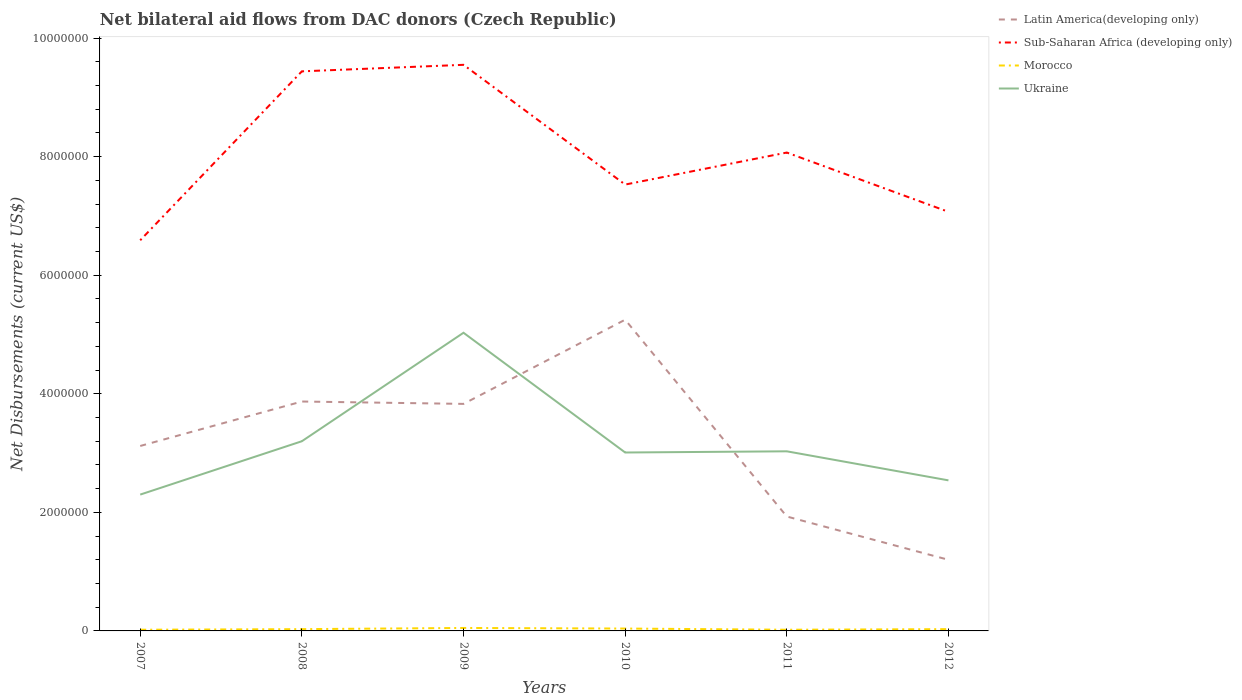Is the number of lines equal to the number of legend labels?
Give a very brief answer. Yes. Across all years, what is the maximum net bilateral aid flows in Sub-Saharan Africa (developing only)?
Provide a succinct answer. 6.59e+06. What is the total net bilateral aid flows in Latin America(developing only) in the graph?
Your response must be concise. -7.10e+05. What is the difference between the highest and the second highest net bilateral aid flows in Sub-Saharan Africa (developing only)?
Provide a short and direct response. 2.96e+06. Is the net bilateral aid flows in Morocco strictly greater than the net bilateral aid flows in Ukraine over the years?
Your answer should be very brief. Yes. How many years are there in the graph?
Provide a short and direct response. 6. What is the difference between two consecutive major ticks on the Y-axis?
Your response must be concise. 2.00e+06. Does the graph contain any zero values?
Give a very brief answer. No. Does the graph contain grids?
Offer a terse response. No. What is the title of the graph?
Your response must be concise. Net bilateral aid flows from DAC donors (Czech Republic). What is the label or title of the X-axis?
Give a very brief answer. Years. What is the label or title of the Y-axis?
Keep it short and to the point. Net Disbursements (current US$). What is the Net Disbursements (current US$) in Latin America(developing only) in 2007?
Give a very brief answer. 3.12e+06. What is the Net Disbursements (current US$) in Sub-Saharan Africa (developing only) in 2007?
Your answer should be very brief. 6.59e+06. What is the Net Disbursements (current US$) in Ukraine in 2007?
Give a very brief answer. 2.30e+06. What is the Net Disbursements (current US$) in Latin America(developing only) in 2008?
Offer a terse response. 3.87e+06. What is the Net Disbursements (current US$) of Sub-Saharan Africa (developing only) in 2008?
Your response must be concise. 9.44e+06. What is the Net Disbursements (current US$) of Morocco in 2008?
Make the answer very short. 3.00e+04. What is the Net Disbursements (current US$) of Ukraine in 2008?
Provide a short and direct response. 3.20e+06. What is the Net Disbursements (current US$) in Latin America(developing only) in 2009?
Your answer should be compact. 3.83e+06. What is the Net Disbursements (current US$) in Sub-Saharan Africa (developing only) in 2009?
Offer a terse response. 9.55e+06. What is the Net Disbursements (current US$) of Morocco in 2009?
Offer a very short reply. 5.00e+04. What is the Net Disbursements (current US$) in Ukraine in 2009?
Ensure brevity in your answer.  5.03e+06. What is the Net Disbursements (current US$) in Latin America(developing only) in 2010?
Offer a very short reply. 5.25e+06. What is the Net Disbursements (current US$) of Sub-Saharan Africa (developing only) in 2010?
Offer a very short reply. 7.53e+06. What is the Net Disbursements (current US$) of Morocco in 2010?
Your answer should be very brief. 4.00e+04. What is the Net Disbursements (current US$) in Ukraine in 2010?
Your response must be concise. 3.01e+06. What is the Net Disbursements (current US$) in Latin America(developing only) in 2011?
Offer a terse response. 1.93e+06. What is the Net Disbursements (current US$) in Sub-Saharan Africa (developing only) in 2011?
Provide a short and direct response. 8.07e+06. What is the Net Disbursements (current US$) in Morocco in 2011?
Your response must be concise. 2.00e+04. What is the Net Disbursements (current US$) in Ukraine in 2011?
Your answer should be very brief. 3.03e+06. What is the Net Disbursements (current US$) in Latin America(developing only) in 2012?
Provide a succinct answer. 1.20e+06. What is the Net Disbursements (current US$) in Sub-Saharan Africa (developing only) in 2012?
Provide a succinct answer. 7.07e+06. What is the Net Disbursements (current US$) in Ukraine in 2012?
Your answer should be compact. 2.54e+06. Across all years, what is the maximum Net Disbursements (current US$) of Latin America(developing only)?
Offer a very short reply. 5.25e+06. Across all years, what is the maximum Net Disbursements (current US$) in Sub-Saharan Africa (developing only)?
Keep it short and to the point. 9.55e+06. Across all years, what is the maximum Net Disbursements (current US$) of Ukraine?
Make the answer very short. 5.03e+06. Across all years, what is the minimum Net Disbursements (current US$) of Latin America(developing only)?
Your answer should be very brief. 1.20e+06. Across all years, what is the minimum Net Disbursements (current US$) in Sub-Saharan Africa (developing only)?
Ensure brevity in your answer.  6.59e+06. Across all years, what is the minimum Net Disbursements (current US$) in Ukraine?
Offer a very short reply. 2.30e+06. What is the total Net Disbursements (current US$) in Latin America(developing only) in the graph?
Your answer should be very brief. 1.92e+07. What is the total Net Disbursements (current US$) of Sub-Saharan Africa (developing only) in the graph?
Provide a short and direct response. 4.82e+07. What is the total Net Disbursements (current US$) in Morocco in the graph?
Keep it short and to the point. 1.90e+05. What is the total Net Disbursements (current US$) of Ukraine in the graph?
Your answer should be compact. 1.91e+07. What is the difference between the Net Disbursements (current US$) of Latin America(developing only) in 2007 and that in 2008?
Give a very brief answer. -7.50e+05. What is the difference between the Net Disbursements (current US$) in Sub-Saharan Africa (developing only) in 2007 and that in 2008?
Provide a succinct answer. -2.85e+06. What is the difference between the Net Disbursements (current US$) of Ukraine in 2007 and that in 2008?
Provide a short and direct response. -9.00e+05. What is the difference between the Net Disbursements (current US$) of Latin America(developing only) in 2007 and that in 2009?
Give a very brief answer. -7.10e+05. What is the difference between the Net Disbursements (current US$) of Sub-Saharan Africa (developing only) in 2007 and that in 2009?
Provide a short and direct response. -2.96e+06. What is the difference between the Net Disbursements (current US$) in Morocco in 2007 and that in 2009?
Your answer should be very brief. -3.00e+04. What is the difference between the Net Disbursements (current US$) of Ukraine in 2007 and that in 2009?
Your answer should be compact. -2.73e+06. What is the difference between the Net Disbursements (current US$) of Latin America(developing only) in 2007 and that in 2010?
Ensure brevity in your answer.  -2.13e+06. What is the difference between the Net Disbursements (current US$) in Sub-Saharan Africa (developing only) in 2007 and that in 2010?
Your answer should be compact. -9.40e+05. What is the difference between the Net Disbursements (current US$) in Ukraine in 2007 and that in 2010?
Your response must be concise. -7.10e+05. What is the difference between the Net Disbursements (current US$) in Latin America(developing only) in 2007 and that in 2011?
Keep it short and to the point. 1.19e+06. What is the difference between the Net Disbursements (current US$) of Sub-Saharan Africa (developing only) in 2007 and that in 2011?
Offer a very short reply. -1.48e+06. What is the difference between the Net Disbursements (current US$) in Ukraine in 2007 and that in 2011?
Your answer should be compact. -7.30e+05. What is the difference between the Net Disbursements (current US$) of Latin America(developing only) in 2007 and that in 2012?
Your answer should be compact. 1.92e+06. What is the difference between the Net Disbursements (current US$) of Sub-Saharan Africa (developing only) in 2007 and that in 2012?
Provide a succinct answer. -4.80e+05. What is the difference between the Net Disbursements (current US$) of Morocco in 2007 and that in 2012?
Provide a succinct answer. -10000. What is the difference between the Net Disbursements (current US$) in Sub-Saharan Africa (developing only) in 2008 and that in 2009?
Make the answer very short. -1.10e+05. What is the difference between the Net Disbursements (current US$) of Morocco in 2008 and that in 2009?
Ensure brevity in your answer.  -2.00e+04. What is the difference between the Net Disbursements (current US$) in Ukraine in 2008 and that in 2009?
Offer a terse response. -1.83e+06. What is the difference between the Net Disbursements (current US$) in Latin America(developing only) in 2008 and that in 2010?
Offer a very short reply. -1.38e+06. What is the difference between the Net Disbursements (current US$) in Sub-Saharan Africa (developing only) in 2008 and that in 2010?
Your answer should be very brief. 1.91e+06. What is the difference between the Net Disbursements (current US$) of Morocco in 2008 and that in 2010?
Your answer should be very brief. -10000. What is the difference between the Net Disbursements (current US$) in Ukraine in 2008 and that in 2010?
Offer a very short reply. 1.90e+05. What is the difference between the Net Disbursements (current US$) of Latin America(developing only) in 2008 and that in 2011?
Offer a very short reply. 1.94e+06. What is the difference between the Net Disbursements (current US$) in Sub-Saharan Africa (developing only) in 2008 and that in 2011?
Your answer should be compact. 1.37e+06. What is the difference between the Net Disbursements (current US$) of Ukraine in 2008 and that in 2011?
Make the answer very short. 1.70e+05. What is the difference between the Net Disbursements (current US$) of Latin America(developing only) in 2008 and that in 2012?
Ensure brevity in your answer.  2.67e+06. What is the difference between the Net Disbursements (current US$) in Sub-Saharan Africa (developing only) in 2008 and that in 2012?
Keep it short and to the point. 2.37e+06. What is the difference between the Net Disbursements (current US$) of Morocco in 2008 and that in 2012?
Your answer should be very brief. 0. What is the difference between the Net Disbursements (current US$) of Ukraine in 2008 and that in 2012?
Give a very brief answer. 6.60e+05. What is the difference between the Net Disbursements (current US$) of Latin America(developing only) in 2009 and that in 2010?
Your response must be concise. -1.42e+06. What is the difference between the Net Disbursements (current US$) in Sub-Saharan Africa (developing only) in 2009 and that in 2010?
Make the answer very short. 2.02e+06. What is the difference between the Net Disbursements (current US$) of Ukraine in 2009 and that in 2010?
Your response must be concise. 2.02e+06. What is the difference between the Net Disbursements (current US$) in Latin America(developing only) in 2009 and that in 2011?
Provide a short and direct response. 1.90e+06. What is the difference between the Net Disbursements (current US$) in Sub-Saharan Africa (developing only) in 2009 and that in 2011?
Provide a short and direct response. 1.48e+06. What is the difference between the Net Disbursements (current US$) of Morocco in 2009 and that in 2011?
Provide a short and direct response. 3.00e+04. What is the difference between the Net Disbursements (current US$) of Ukraine in 2009 and that in 2011?
Provide a succinct answer. 2.00e+06. What is the difference between the Net Disbursements (current US$) of Latin America(developing only) in 2009 and that in 2012?
Your answer should be very brief. 2.63e+06. What is the difference between the Net Disbursements (current US$) of Sub-Saharan Africa (developing only) in 2009 and that in 2012?
Your answer should be compact. 2.48e+06. What is the difference between the Net Disbursements (current US$) of Ukraine in 2009 and that in 2012?
Make the answer very short. 2.49e+06. What is the difference between the Net Disbursements (current US$) in Latin America(developing only) in 2010 and that in 2011?
Ensure brevity in your answer.  3.32e+06. What is the difference between the Net Disbursements (current US$) in Sub-Saharan Africa (developing only) in 2010 and that in 2011?
Make the answer very short. -5.40e+05. What is the difference between the Net Disbursements (current US$) in Morocco in 2010 and that in 2011?
Provide a succinct answer. 2.00e+04. What is the difference between the Net Disbursements (current US$) in Ukraine in 2010 and that in 2011?
Provide a short and direct response. -2.00e+04. What is the difference between the Net Disbursements (current US$) of Latin America(developing only) in 2010 and that in 2012?
Your answer should be very brief. 4.05e+06. What is the difference between the Net Disbursements (current US$) of Ukraine in 2010 and that in 2012?
Your response must be concise. 4.70e+05. What is the difference between the Net Disbursements (current US$) of Latin America(developing only) in 2011 and that in 2012?
Your answer should be very brief. 7.30e+05. What is the difference between the Net Disbursements (current US$) of Sub-Saharan Africa (developing only) in 2011 and that in 2012?
Offer a very short reply. 1.00e+06. What is the difference between the Net Disbursements (current US$) of Ukraine in 2011 and that in 2012?
Make the answer very short. 4.90e+05. What is the difference between the Net Disbursements (current US$) in Latin America(developing only) in 2007 and the Net Disbursements (current US$) in Sub-Saharan Africa (developing only) in 2008?
Your answer should be compact. -6.32e+06. What is the difference between the Net Disbursements (current US$) of Latin America(developing only) in 2007 and the Net Disbursements (current US$) of Morocco in 2008?
Ensure brevity in your answer.  3.09e+06. What is the difference between the Net Disbursements (current US$) of Latin America(developing only) in 2007 and the Net Disbursements (current US$) of Ukraine in 2008?
Make the answer very short. -8.00e+04. What is the difference between the Net Disbursements (current US$) of Sub-Saharan Africa (developing only) in 2007 and the Net Disbursements (current US$) of Morocco in 2008?
Provide a succinct answer. 6.56e+06. What is the difference between the Net Disbursements (current US$) of Sub-Saharan Africa (developing only) in 2007 and the Net Disbursements (current US$) of Ukraine in 2008?
Provide a short and direct response. 3.39e+06. What is the difference between the Net Disbursements (current US$) in Morocco in 2007 and the Net Disbursements (current US$) in Ukraine in 2008?
Make the answer very short. -3.18e+06. What is the difference between the Net Disbursements (current US$) in Latin America(developing only) in 2007 and the Net Disbursements (current US$) in Sub-Saharan Africa (developing only) in 2009?
Provide a succinct answer. -6.43e+06. What is the difference between the Net Disbursements (current US$) of Latin America(developing only) in 2007 and the Net Disbursements (current US$) of Morocco in 2009?
Make the answer very short. 3.07e+06. What is the difference between the Net Disbursements (current US$) in Latin America(developing only) in 2007 and the Net Disbursements (current US$) in Ukraine in 2009?
Ensure brevity in your answer.  -1.91e+06. What is the difference between the Net Disbursements (current US$) of Sub-Saharan Africa (developing only) in 2007 and the Net Disbursements (current US$) of Morocco in 2009?
Your answer should be very brief. 6.54e+06. What is the difference between the Net Disbursements (current US$) of Sub-Saharan Africa (developing only) in 2007 and the Net Disbursements (current US$) of Ukraine in 2009?
Your answer should be very brief. 1.56e+06. What is the difference between the Net Disbursements (current US$) of Morocco in 2007 and the Net Disbursements (current US$) of Ukraine in 2009?
Provide a short and direct response. -5.01e+06. What is the difference between the Net Disbursements (current US$) of Latin America(developing only) in 2007 and the Net Disbursements (current US$) of Sub-Saharan Africa (developing only) in 2010?
Make the answer very short. -4.41e+06. What is the difference between the Net Disbursements (current US$) in Latin America(developing only) in 2007 and the Net Disbursements (current US$) in Morocco in 2010?
Provide a short and direct response. 3.08e+06. What is the difference between the Net Disbursements (current US$) in Sub-Saharan Africa (developing only) in 2007 and the Net Disbursements (current US$) in Morocco in 2010?
Offer a terse response. 6.55e+06. What is the difference between the Net Disbursements (current US$) of Sub-Saharan Africa (developing only) in 2007 and the Net Disbursements (current US$) of Ukraine in 2010?
Provide a succinct answer. 3.58e+06. What is the difference between the Net Disbursements (current US$) in Morocco in 2007 and the Net Disbursements (current US$) in Ukraine in 2010?
Make the answer very short. -2.99e+06. What is the difference between the Net Disbursements (current US$) of Latin America(developing only) in 2007 and the Net Disbursements (current US$) of Sub-Saharan Africa (developing only) in 2011?
Your answer should be very brief. -4.95e+06. What is the difference between the Net Disbursements (current US$) of Latin America(developing only) in 2007 and the Net Disbursements (current US$) of Morocco in 2011?
Your answer should be compact. 3.10e+06. What is the difference between the Net Disbursements (current US$) of Sub-Saharan Africa (developing only) in 2007 and the Net Disbursements (current US$) of Morocco in 2011?
Make the answer very short. 6.57e+06. What is the difference between the Net Disbursements (current US$) of Sub-Saharan Africa (developing only) in 2007 and the Net Disbursements (current US$) of Ukraine in 2011?
Make the answer very short. 3.56e+06. What is the difference between the Net Disbursements (current US$) in Morocco in 2007 and the Net Disbursements (current US$) in Ukraine in 2011?
Provide a short and direct response. -3.01e+06. What is the difference between the Net Disbursements (current US$) of Latin America(developing only) in 2007 and the Net Disbursements (current US$) of Sub-Saharan Africa (developing only) in 2012?
Provide a succinct answer. -3.95e+06. What is the difference between the Net Disbursements (current US$) in Latin America(developing only) in 2007 and the Net Disbursements (current US$) in Morocco in 2012?
Offer a very short reply. 3.09e+06. What is the difference between the Net Disbursements (current US$) in Latin America(developing only) in 2007 and the Net Disbursements (current US$) in Ukraine in 2012?
Keep it short and to the point. 5.80e+05. What is the difference between the Net Disbursements (current US$) in Sub-Saharan Africa (developing only) in 2007 and the Net Disbursements (current US$) in Morocco in 2012?
Give a very brief answer. 6.56e+06. What is the difference between the Net Disbursements (current US$) of Sub-Saharan Africa (developing only) in 2007 and the Net Disbursements (current US$) of Ukraine in 2012?
Provide a short and direct response. 4.05e+06. What is the difference between the Net Disbursements (current US$) in Morocco in 2007 and the Net Disbursements (current US$) in Ukraine in 2012?
Provide a succinct answer. -2.52e+06. What is the difference between the Net Disbursements (current US$) in Latin America(developing only) in 2008 and the Net Disbursements (current US$) in Sub-Saharan Africa (developing only) in 2009?
Make the answer very short. -5.68e+06. What is the difference between the Net Disbursements (current US$) of Latin America(developing only) in 2008 and the Net Disbursements (current US$) of Morocco in 2009?
Your answer should be compact. 3.82e+06. What is the difference between the Net Disbursements (current US$) in Latin America(developing only) in 2008 and the Net Disbursements (current US$) in Ukraine in 2009?
Keep it short and to the point. -1.16e+06. What is the difference between the Net Disbursements (current US$) in Sub-Saharan Africa (developing only) in 2008 and the Net Disbursements (current US$) in Morocco in 2009?
Your answer should be compact. 9.39e+06. What is the difference between the Net Disbursements (current US$) in Sub-Saharan Africa (developing only) in 2008 and the Net Disbursements (current US$) in Ukraine in 2009?
Your answer should be compact. 4.41e+06. What is the difference between the Net Disbursements (current US$) in Morocco in 2008 and the Net Disbursements (current US$) in Ukraine in 2009?
Offer a terse response. -5.00e+06. What is the difference between the Net Disbursements (current US$) of Latin America(developing only) in 2008 and the Net Disbursements (current US$) of Sub-Saharan Africa (developing only) in 2010?
Keep it short and to the point. -3.66e+06. What is the difference between the Net Disbursements (current US$) in Latin America(developing only) in 2008 and the Net Disbursements (current US$) in Morocco in 2010?
Offer a terse response. 3.83e+06. What is the difference between the Net Disbursements (current US$) of Latin America(developing only) in 2008 and the Net Disbursements (current US$) of Ukraine in 2010?
Offer a very short reply. 8.60e+05. What is the difference between the Net Disbursements (current US$) of Sub-Saharan Africa (developing only) in 2008 and the Net Disbursements (current US$) of Morocco in 2010?
Your answer should be very brief. 9.40e+06. What is the difference between the Net Disbursements (current US$) in Sub-Saharan Africa (developing only) in 2008 and the Net Disbursements (current US$) in Ukraine in 2010?
Offer a very short reply. 6.43e+06. What is the difference between the Net Disbursements (current US$) of Morocco in 2008 and the Net Disbursements (current US$) of Ukraine in 2010?
Your answer should be compact. -2.98e+06. What is the difference between the Net Disbursements (current US$) in Latin America(developing only) in 2008 and the Net Disbursements (current US$) in Sub-Saharan Africa (developing only) in 2011?
Ensure brevity in your answer.  -4.20e+06. What is the difference between the Net Disbursements (current US$) in Latin America(developing only) in 2008 and the Net Disbursements (current US$) in Morocco in 2011?
Offer a terse response. 3.85e+06. What is the difference between the Net Disbursements (current US$) of Latin America(developing only) in 2008 and the Net Disbursements (current US$) of Ukraine in 2011?
Your answer should be very brief. 8.40e+05. What is the difference between the Net Disbursements (current US$) of Sub-Saharan Africa (developing only) in 2008 and the Net Disbursements (current US$) of Morocco in 2011?
Provide a succinct answer. 9.42e+06. What is the difference between the Net Disbursements (current US$) of Sub-Saharan Africa (developing only) in 2008 and the Net Disbursements (current US$) of Ukraine in 2011?
Your response must be concise. 6.41e+06. What is the difference between the Net Disbursements (current US$) of Latin America(developing only) in 2008 and the Net Disbursements (current US$) of Sub-Saharan Africa (developing only) in 2012?
Your response must be concise. -3.20e+06. What is the difference between the Net Disbursements (current US$) of Latin America(developing only) in 2008 and the Net Disbursements (current US$) of Morocco in 2012?
Keep it short and to the point. 3.84e+06. What is the difference between the Net Disbursements (current US$) in Latin America(developing only) in 2008 and the Net Disbursements (current US$) in Ukraine in 2012?
Offer a very short reply. 1.33e+06. What is the difference between the Net Disbursements (current US$) of Sub-Saharan Africa (developing only) in 2008 and the Net Disbursements (current US$) of Morocco in 2012?
Keep it short and to the point. 9.41e+06. What is the difference between the Net Disbursements (current US$) in Sub-Saharan Africa (developing only) in 2008 and the Net Disbursements (current US$) in Ukraine in 2012?
Your response must be concise. 6.90e+06. What is the difference between the Net Disbursements (current US$) of Morocco in 2008 and the Net Disbursements (current US$) of Ukraine in 2012?
Your answer should be compact. -2.51e+06. What is the difference between the Net Disbursements (current US$) in Latin America(developing only) in 2009 and the Net Disbursements (current US$) in Sub-Saharan Africa (developing only) in 2010?
Ensure brevity in your answer.  -3.70e+06. What is the difference between the Net Disbursements (current US$) in Latin America(developing only) in 2009 and the Net Disbursements (current US$) in Morocco in 2010?
Offer a terse response. 3.79e+06. What is the difference between the Net Disbursements (current US$) in Latin America(developing only) in 2009 and the Net Disbursements (current US$) in Ukraine in 2010?
Offer a very short reply. 8.20e+05. What is the difference between the Net Disbursements (current US$) in Sub-Saharan Africa (developing only) in 2009 and the Net Disbursements (current US$) in Morocco in 2010?
Provide a succinct answer. 9.51e+06. What is the difference between the Net Disbursements (current US$) of Sub-Saharan Africa (developing only) in 2009 and the Net Disbursements (current US$) of Ukraine in 2010?
Offer a very short reply. 6.54e+06. What is the difference between the Net Disbursements (current US$) in Morocco in 2009 and the Net Disbursements (current US$) in Ukraine in 2010?
Ensure brevity in your answer.  -2.96e+06. What is the difference between the Net Disbursements (current US$) of Latin America(developing only) in 2009 and the Net Disbursements (current US$) of Sub-Saharan Africa (developing only) in 2011?
Ensure brevity in your answer.  -4.24e+06. What is the difference between the Net Disbursements (current US$) of Latin America(developing only) in 2009 and the Net Disbursements (current US$) of Morocco in 2011?
Your answer should be very brief. 3.81e+06. What is the difference between the Net Disbursements (current US$) in Sub-Saharan Africa (developing only) in 2009 and the Net Disbursements (current US$) in Morocco in 2011?
Offer a terse response. 9.53e+06. What is the difference between the Net Disbursements (current US$) of Sub-Saharan Africa (developing only) in 2009 and the Net Disbursements (current US$) of Ukraine in 2011?
Give a very brief answer. 6.52e+06. What is the difference between the Net Disbursements (current US$) of Morocco in 2009 and the Net Disbursements (current US$) of Ukraine in 2011?
Provide a succinct answer. -2.98e+06. What is the difference between the Net Disbursements (current US$) of Latin America(developing only) in 2009 and the Net Disbursements (current US$) of Sub-Saharan Africa (developing only) in 2012?
Give a very brief answer. -3.24e+06. What is the difference between the Net Disbursements (current US$) in Latin America(developing only) in 2009 and the Net Disbursements (current US$) in Morocco in 2012?
Ensure brevity in your answer.  3.80e+06. What is the difference between the Net Disbursements (current US$) in Latin America(developing only) in 2009 and the Net Disbursements (current US$) in Ukraine in 2012?
Offer a terse response. 1.29e+06. What is the difference between the Net Disbursements (current US$) in Sub-Saharan Africa (developing only) in 2009 and the Net Disbursements (current US$) in Morocco in 2012?
Your answer should be compact. 9.52e+06. What is the difference between the Net Disbursements (current US$) of Sub-Saharan Africa (developing only) in 2009 and the Net Disbursements (current US$) of Ukraine in 2012?
Keep it short and to the point. 7.01e+06. What is the difference between the Net Disbursements (current US$) of Morocco in 2009 and the Net Disbursements (current US$) of Ukraine in 2012?
Keep it short and to the point. -2.49e+06. What is the difference between the Net Disbursements (current US$) in Latin America(developing only) in 2010 and the Net Disbursements (current US$) in Sub-Saharan Africa (developing only) in 2011?
Your answer should be very brief. -2.82e+06. What is the difference between the Net Disbursements (current US$) of Latin America(developing only) in 2010 and the Net Disbursements (current US$) of Morocco in 2011?
Provide a succinct answer. 5.23e+06. What is the difference between the Net Disbursements (current US$) of Latin America(developing only) in 2010 and the Net Disbursements (current US$) of Ukraine in 2011?
Give a very brief answer. 2.22e+06. What is the difference between the Net Disbursements (current US$) in Sub-Saharan Africa (developing only) in 2010 and the Net Disbursements (current US$) in Morocco in 2011?
Ensure brevity in your answer.  7.51e+06. What is the difference between the Net Disbursements (current US$) in Sub-Saharan Africa (developing only) in 2010 and the Net Disbursements (current US$) in Ukraine in 2011?
Ensure brevity in your answer.  4.50e+06. What is the difference between the Net Disbursements (current US$) of Morocco in 2010 and the Net Disbursements (current US$) of Ukraine in 2011?
Ensure brevity in your answer.  -2.99e+06. What is the difference between the Net Disbursements (current US$) in Latin America(developing only) in 2010 and the Net Disbursements (current US$) in Sub-Saharan Africa (developing only) in 2012?
Your response must be concise. -1.82e+06. What is the difference between the Net Disbursements (current US$) of Latin America(developing only) in 2010 and the Net Disbursements (current US$) of Morocco in 2012?
Offer a very short reply. 5.22e+06. What is the difference between the Net Disbursements (current US$) of Latin America(developing only) in 2010 and the Net Disbursements (current US$) of Ukraine in 2012?
Offer a very short reply. 2.71e+06. What is the difference between the Net Disbursements (current US$) of Sub-Saharan Africa (developing only) in 2010 and the Net Disbursements (current US$) of Morocco in 2012?
Offer a terse response. 7.50e+06. What is the difference between the Net Disbursements (current US$) in Sub-Saharan Africa (developing only) in 2010 and the Net Disbursements (current US$) in Ukraine in 2012?
Give a very brief answer. 4.99e+06. What is the difference between the Net Disbursements (current US$) of Morocco in 2010 and the Net Disbursements (current US$) of Ukraine in 2012?
Your answer should be compact. -2.50e+06. What is the difference between the Net Disbursements (current US$) in Latin America(developing only) in 2011 and the Net Disbursements (current US$) in Sub-Saharan Africa (developing only) in 2012?
Give a very brief answer. -5.14e+06. What is the difference between the Net Disbursements (current US$) in Latin America(developing only) in 2011 and the Net Disbursements (current US$) in Morocco in 2012?
Provide a succinct answer. 1.90e+06. What is the difference between the Net Disbursements (current US$) of Latin America(developing only) in 2011 and the Net Disbursements (current US$) of Ukraine in 2012?
Ensure brevity in your answer.  -6.10e+05. What is the difference between the Net Disbursements (current US$) of Sub-Saharan Africa (developing only) in 2011 and the Net Disbursements (current US$) of Morocco in 2012?
Provide a short and direct response. 8.04e+06. What is the difference between the Net Disbursements (current US$) in Sub-Saharan Africa (developing only) in 2011 and the Net Disbursements (current US$) in Ukraine in 2012?
Ensure brevity in your answer.  5.53e+06. What is the difference between the Net Disbursements (current US$) in Morocco in 2011 and the Net Disbursements (current US$) in Ukraine in 2012?
Offer a terse response. -2.52e+06. What is the average Net Disbursements (current US$) in Latin America(developing only) per year?
Your answer should be very brief. 3.20e+06. What is the average Net Disbursements (current US$) of Sub-Saharan Africa (developing only) per year?
Your answer should be compact. 8.04e+06. What is the average Net Disbursements (current US$) of Morocco per year?
Offer a very short reply. 3.17e+04. What is the average Net Disbursements (current US$) in Ukraine per year?
Ensure brevity in your answer.  3.18e+06. In the year 2007, what is the difference between the Net Disbursements (current US$) in Latin America(developing only) and Net Disbursements (current US$) in Sub-Saharan Africa (developing only)?
Provide a short and direct response. -3.47e+06. In the year 2007, what is the difference between the Net Disbursements (current US$) in Latin America(developing only) and Net Disbursements (current US$) in Morocco?
Your answer should be very brief. 3.10e+06. In the year 2007, what is the difference between the Net Disbursements (current US$) in Latin America(developing only) and Net Disbursements (current US$) in Ukraine?
Make the answer very short. 8.20e+05. In the year 2007, what is the difference between the Net Disbursements (current US$) in Sub-Saharan Africa (developing only) and Net Disbursements (current US$) in Morocco?
Make the answer very short. 6.57e+06. In the year 2007, what is the difference between the Net Disbursements (current US$) of Sub-Saharan Africa (developing only) and Net Disbursements (current US$) of Ukraine?
Your answer should be very brief. 4.29e+06. In the year 2007, what is the difference between the Net Disbursements (current US$) in Morocco and Net Disbursements (current US$) in Ukraine?
Offer a terse response. -2.28e+06. In the year 2008, what is the difference between the Net Disbursements (current US$) in Latin America(developing only) and Net Disbursements (current US$) in Sub-Saharan Africa (developing only)?
Provide a short and direct response. -5.57e+06. In the year 2008, what is the difference between the Net Disbursements (current US$) of Latin America(developing only) and Net Disbursements (current US$) of Morocco?
Your answer should be compact. 3.84e+06. In the year 2008, what is the difference between the Net Disbursements (current US$) in Latin America(developing only) and Net Disbursements (current US$) in Ukraine?
Provide a succinct answer. 6.70e+05. In the year 2008, what is the difference between the Net Disbursements (current US$) of Sub-Saharan Africa (developing only) and Net Disbursements (current US$) of Morocco?
Provide a short and direct response. 9.41e+06. In the year 2008, what is the difference between the Net Disbursements (current US$) in Sub-Saharan Africa (developing only) and Net Disbursements (current US$) in Ukraine?
Provide a succinct answer. 6.24e+06. In the year 2008, what is the difference between the Net Disbursements (current US$) of Morocco and Net Disbursements (current US$) of Ukraine?
Provide a short and direct response. -3.17e+06. In the year 2009, what is the difference between the Net Disbursements (current US$) of Latin America(developing only) and Net Disbursements (current US$) of Sub-Saharan Africa (developing only)?
Your answer should be compact. -5.72e+06. In the year 2009, what is the difference between the Net Disbursements (current US$) in Latin America(developing only) and Net Disbursements (current US$) in Morocco?
Keep it short and to the point. 3.78e+06. In the year 2009, what is the difference between the Net Disbursements (current US$) of Latin America(developing only) and Net Disbursements (current US$) of Ukraine?
Your answer should be very brief. -1.20e+06. In the year 2009, what is the difference between the Net Disbursements (current US$) of Sub-Saharan Africa (developing only) and Net Disbursements (current US$) of Morocco?
Your answer should be compact. 9.50e+06. In the year 2009, what is the difference between the Net Disbursements (current US$) of Sub-Saharan Africa (developing only) and Net Disbursements (current US$) of Ukraine?
Your answer should be very brief. 4.52e+06. In the year 2009, what is the difference between the Net Disbursements (current US$) of Morocco and Net Disbursements (current US$) of Ukraine?
Ensure brevity in your answer.  -4.98e+06. In the year 2010, what is the difference between the Net Disbursements (current US$) in Latin America(developing only) and Net Disbursements (current US$) in Sub-Saharan Africa (developing only)?
Offer a terse response. -2.28e+06. In the year 2010, what is the difference between the Net Disbursements (current US$) of Latin America(developing only) and Net Disbursements (current US$) of Morocco?
Your response must be concise. 5.21e+06. In the year 2010, what is the difference between the Net Disbursements (current US$) of Latin America(developing only) and Net Disbursements (current US$) of Ukraine?
Your response must be concise. 2.24e+06. In the year 2010, what is the difference between the Net Disbursements (current US$) of Sub-Saharan Africa (developing only) and Net Disbursements (current US$) of Morocco?
Your answer should be very brief. 7.49e+06. In the year 2010, what is the difference between the Net Disbursements (current US$) in Sub-Saharan Africa (developing only) and Net Disbursements (current US$) in Ukraine?
Make the answer very short. 4.52e+06. In the year 2010, what is the difference between the Net Disbursements (current US$) in Morocco and Net Disbursements (current US$) in Ukraine?
Offer a terse response. -2.97e+06. In the year 2011, what is the difference between the Net Disbursements (current US$) in Latin America(developing only) and Net Disbursements (current US$) in Sub-Saharan Africa (developing only)?
Ensure brevity in your answer.  -6.14e+06. In the year 2011, what is the difference between the Net Disbursements (current US$) in Latin America(developing only) and Net Disbursements (current US$) in Morocco?
Your response must be concise. 1.91e+06. In the year 2011, what is the difference between the Net Disbursements (current US$) of Latin America(developing only) and Net Disbursements (current US$) of Ukraine?
Ensure brevity in your answer.  -1.10e+06. In the year 2011, what is the difference between the Net Disbursements (current US$) in Sub-Saharan Africa (developing only) and Net Disbursements (current US$) in Morocco?
Provide a succinct answer. 8.05e+06. In the year 2011, what is the difference between the Net Disbursements (current US$) in Sub-Saharan Africa (developing only) and Net Disbursements (current US$) in Ukraine?
Provide a short and direct response. 5.04e+06. In the year 2011, what is the difference between the Net Disbursements (current US$) in Morocco and Net Disbursements (current US$) in Ukraine?
Provide a succinct answer. -3.01e+06. In the year 2012, what is the difference between the Net Disbursements (current US$) in Latin America(developing only) and Net Disbursements (current US$) in Sub-Saharan Africa (developing only)?
Your answer should be compact. -5.87e+06. In the year 2012, what is the difference between the Net Disbursements (current US$) of Latin America(developing only) and Net Disbursements (current US$) of Morocco?
Provide a short and direct response. 1.17e+06. In the year 2012, what is the difference between the Net Disbursements (current US$) in Latin America(developing only) and Net Disbursements (current US$) in Ukraine?
Your answer should be very brief. -1.34e+06. In the year 2012, what is the difference between the Net Disbursements (current US$) of Sub-Saharan Africa (developing only) and Net Disbursements (current US$) of Morocco?
Give a very brief answer. 7.04e+06. In the year 2012, what is the difference between the Net Disbursements (current US$) of Sub-Saharan Africa (developing only) and Net Disbursements (current US$) of Ukraine?
Give a very brief answer. 4.53e+06. In the year 2012, what is the difference between the Net Disbursements (current US$) of Morocco and Net Disbursements (current US$) of Ukraine?
Your response must be concise. -2.51e+06. What is the ratio of the Net Disbursements (current US$) of Latin America(developing only) in 2007 to that in 2008?
Offer a very short reply. 0.81. What is the ratio of the Net Disbursements (current US$) of Sub-Saharan Africa (developing only) in 2007 to that in 2008?
Ensure brevity in your answer.  0.7. What is the ratio of the Net Disbursements (current US$) of Ukraine in 2007 to that in 2008?
Offer a terse response. 0.72. What is the ratio of the Net Disbursements (current US$) in Latin America(developing only) in 2007 to that in 2009?
Provide a short and direct response. 0.81. What is the ratio of the Net Disbursements (current US$) in Sub-Saharan Africa (developing only) in 2007 to that in 2009?
Make the answer very short. 0.69. What is the ratio of the Net Disbursements (current US$) of Ukraine in 2007 to that in 2009?
Your response must be concise. 0.46. What is the ratio of the Net Disbursements (current US$) in Latin America(developing only) in 2007 to that in 2010?
Your answer should be very brief. 0.59. What is the ratio of the Net Disbursements (current US$) of Sub-Saharan Africa (developing only) in 2007 to that in 2010?
Ensure brevity in your answer.  0.88. What is the ratio of the Net Disbursements (current US$) in Morocco in 2007 to that in 2010?
Provide a short and direct response. 0.5. What is the ratio of the Net Disbursements (current US$) in Ukraine in 2007 to that in 2010?
Your answer should be very brief. 0.76. What is the ratio of the Net Disbursements (current US$) in Latin America(developing only) in 2007 to that in 2011?
Provide a short and direct response. 1.62. What is the ratio of the Net Disbursements (current US$) in Sub-Saharan Africa (developing only) in 2007 to that in 2011?
Give a very brief answer. 0.82. What is the ratio of the Net Disbursements (current US$) in Ukraine in 2007 to that in 2011?
Your answer should be compact. 0.76. What is the ratio of the Net Disbursements (current US$) in Latin America(developing only) in 2007 to that in 2012?
Your answer should be very brief. 2.6. What is the ratio of the Net Disbursements (current US$) in Sub-Saharan Africa (developing only) in 2007 to that in 2012?
Your answer should be compact. 0.93. What is the ratio of the Net Disbursements (current US$) in Ukraine in 2007 to that in 2012?
Provide a succinct answer. 0.91. What is the ratio of the Net Disbursements (current US$) of Latin America(developing only) in 2008 to that in 2009?
Provide a succinct answer. 1.01. What is the ratio of the Net Disbursements (current US$) in Ukraine in 2008 to that in 2009?
Your answer should be very brief. 0.64. What is the ratio of the Net Disbursements (current US$) of Latin America(developing only) in 2008 to that in 2010?
Provide a short and direct response. 0.74. What is the ratio of the Net Disbursements (current US$) in Sub-Saharan Africa (developing only) in 2008 to that in 2010?
Provide a short and direct response. 1.25. What is the ratio of the Net Disbursements (current US$) of Morocco in 2008 to that in 2010?
Provide a short and direct response. 0.75. What is the ratio of the Net Disbursements (current US$) in Ukraine in 2008 to that in 2010?
Give a very brief answer. 1.06. What is the ratio of the Net Disbursements (current US$) in Latin America(developing only) in 2008 to that in 2011?
Your answer should be very brief. 2.01. What is the ratio of the Net Disbursements (current US$) in Sub-Saharan Africa (developing only) in 2008 to that in 2011?
Offer a terse response. 1.17. What is the ratio of the Net Disbursements (current US$) in Ukraine in 2008 to that in 2011?
Your response must be concise. 1.06. What is the ratio of the Net Disbursements (current US$) in Latin America(developing only) in 2008 to that in 2012?
Offer a very short reply. 3.23. What is the ratio of the Net Disbursements (current US$) in Sub-Saharan Africa (developing only) in 2008 to that in 2012?
Offer a terse response. 1.34. What is the ratio of the Net Disbursements (current US$) in Ukraine in 2008 to that in 2012?
Offer a terse response. 1.26. What is the ratio of the Net Disbursements (current US$) of Latin America(developing only) in 2009 to that in 2010?
Give a very brief answer. 0.73. What is the ratio of the Net Disbursements (current US$) of Sub-Saharan Africa (developing only) in 2009 to that in 2010?
Offer a terse response. 1.27. What is the ratio of the Net Disbursements (current US$) of Ukraine in 2009 to that in 2010?
Provide a short and direct response. 1.67. What is the ratio of the Net Disbursements (current US$) in Latin America(developing only) in 2009 to that in 2011?
Make the answer very short. 1.98. What is the ratio of the Net Disbursements (current US$) of Sub-Saharan Africa (developing only) in 2009 to that in 2011?
Offer a terse response. 1.18. What is the ratio of the Net Disbursements (current US$) of Morocco in 2009 to that in 2011?
Provide a short and direct response. 2.5. What is the ratio of the Net Disbursements (current US$) in Ukraine in 2009 to that in 2011?
Keep it short and to the point. 1.66. What is the ratio of the Net Disbursements (current US$) of Latin America(developing only) in 2009 to that in 2012?
Keep it short and to the point. 3.19. What is the ratio of the Net Disbursements (current US$) of Sub-Saharan Africa (developing only) in 2009 to that in 2012?
Provide a short and direct response. 1.35. What is the ratio of the Net Disbursements (current US$) in Ukraine in 2009 to that in 2012?
Offer a terse response. 1.98. What is the ratio of the Net Disbursements (current US$) of Latin America(developing only) in 2010 to that in 2011?
Your answer should be compact. 2.72. What is the ratio of the Net Disbursements (current US$) in Sub-Saharan Africa (developing only) in 2010 to that in 2011?
Keep it short and to the point. 0.93. What is the ratio of the Net Disbursements (current US$) of Morocco in 2010 to that in 2011?
Your answer should be very brief. 2. What is the ratio of the Net Disbursements (current US$) of Ukraine in 2010 to that in 2011?
Make the answer very short. 0.99. What is the ratio of the Net Disbursements (current US$) in Latin America(developing only) in 2010 to that in 2012?
Your answer should be very brief. 4.38. What is the ratio of the Net Disbursements (current US$) of Sub-Saharan Africa (developing only) in 2010 to that in 2012?
Your answer should be compact. 1.07. What is the ratio of the Net Disbursements (current US$) in Ukraine in 2010 to that in 2012?
Offer a terse response. 1.19. What is the ratio of the Net Disbursements (current US$) of Latin America(developing only) in 2011 to that in 2012?
Provide a succinct answer. 1.61. What is the ratio of the Net Disbursements (current US$) of Sub-Saharan Africa (developing only) in 2011 to that in 2012?
Make the answer very short. 1.14. What is the ratio of the Net Disbursements (current US$) of Ukraine in 2011 to that in 2012?
Provide a succinct answer. 1.19. What is the difference between the highest and the second highest Net Disbursements (current US$) in Latin America(developing only)?
Your answer should be compact. 1.38e+06. What is the difference between the highest and the second highest Net Disbursements (current US$) in Ukraine?
Make the answer very short. 1.83e+06. What is the difference between the highest and the lowest Net Disbursements (current US$) of Latin America(developing only)?
Keep it short and to the point. 4.05e+06. What is the difference between the highest and the lowest Net Disbursements (current US$) of Sub-Saharan Africa (developing only)?
Provide a succinct answer. 2.96e+06. What is the difference between the highest and the lowest Net Disbursements (current US$) of Ukraine?
Provide a short and direct response. 2.73e+06. 